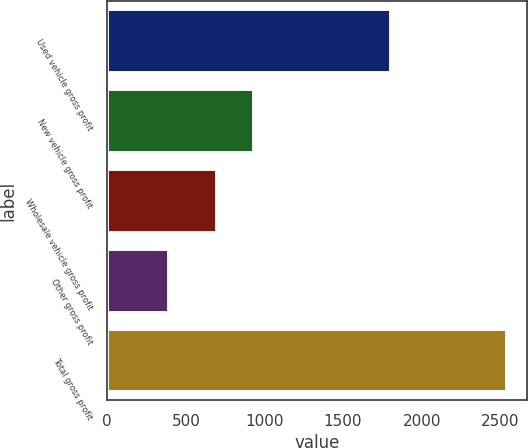Convert chart to OTSL. <chart><loc_0><loc_0><loc_500><loc_500><bar_chart><fcel>Used vehicle gross profit<fcel>New vehicle gross profit<fcel>Wholesale vehicle gross profit<fcel>Other gross profit<fcel>Total gross profit<nl><fcel>1808<fcel>934<fcel>700<fcel>391<fcel>2544<nl></chart> 